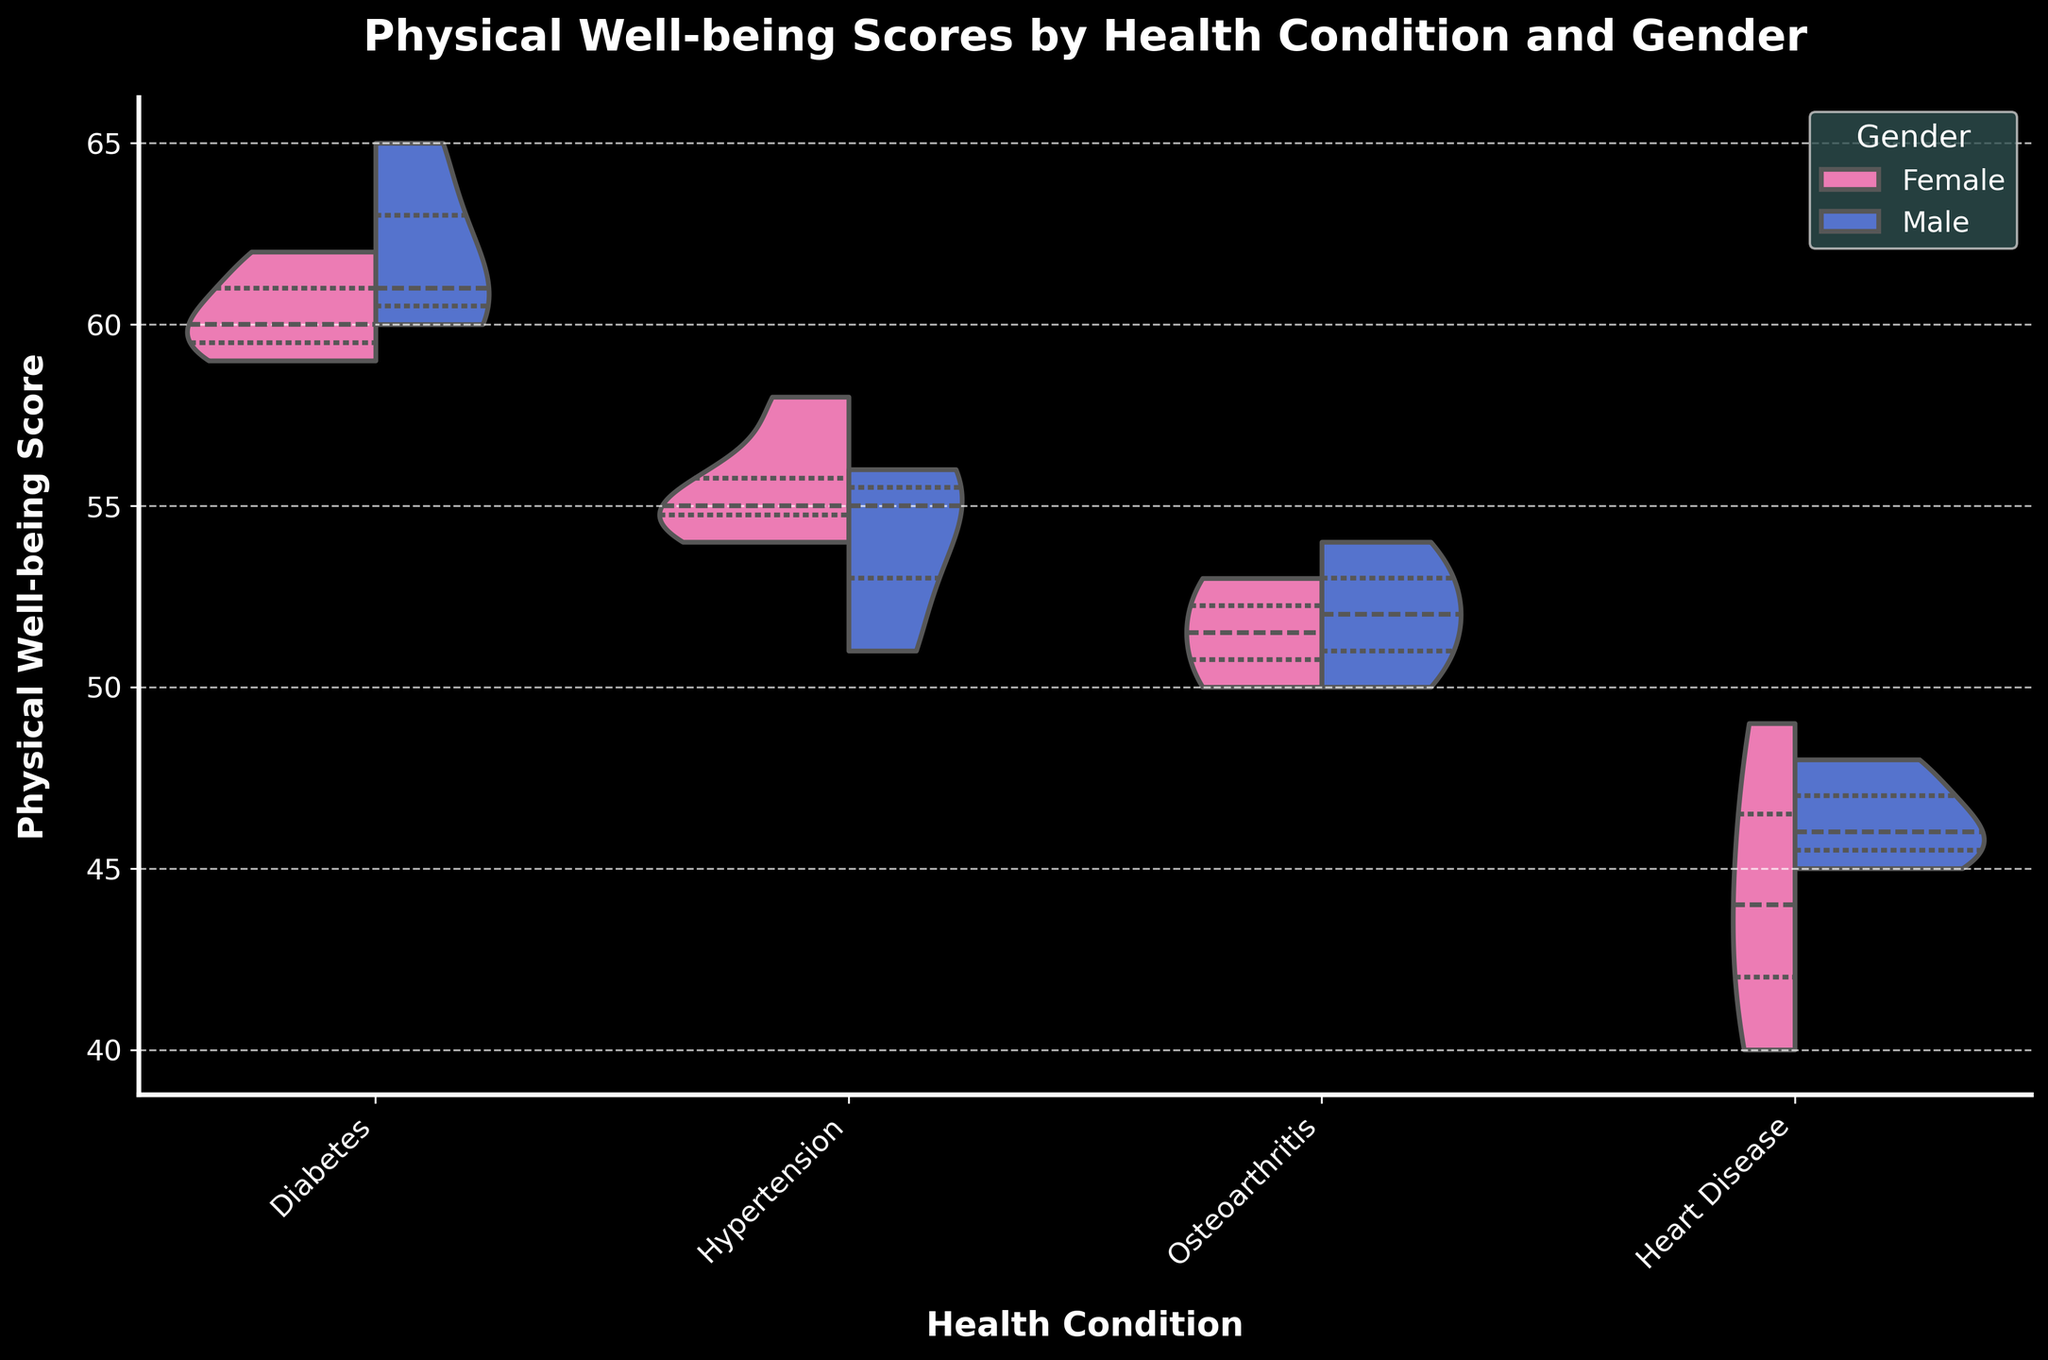What is the title of the chart? The title is displayed at the top center of the chart, indicating the overall context of the data represented.
Answer: Physical Well-being Scores by Health Condition and Gender What are the two gender categories shown in the violin plot? Observing the legend, we can see two different colors representing "Female" and "Male" categories.
Answer: Female and Male Which health condition shows the highest median Physical Well-being Score for females? By looking at the quartile lines within the violin plots for females, we identify the median for each condition and compare.
Answer: Diabetes How does the Physical Well-being Score distribution for males with Heart Disease compare to females with Heart Disease? By examining the male and female distributions within the Heart Disease category, we see the range and quartile distributions.
Answer: Males have a lower median score with a narrower distribution Which health condition has the widest range of Physical Well-being Scores for females? By comparing the spread of the violin plots for females across different health conditions, the condition with the largest spread is identified.
Answer: Hypertension What is the median Physical Well-being Score for males with Diabetes? The median score is represented by the thick middle line in the male section of the Diabetes violin plot.
Answer: 61 Which gender shows a greater variability in Physical Well-being Scores for Osteoarthritis? By observing the width and spread of the violin plots for both genders within the Osteoarthritis category, we can determine variability.
Answer: Male How does the median Physical Well-being Score for females with Diabetes compare to females with Hypertension? We compare the median quartile lines (thick lines) within the violin plots for females under Diabetes and Hypertension.
Answer: Higher in Diabetes Which health condition shows the closest median Physical Well-being Scores between males and females? By comparing median lines for each health condition category, observe which one has the least difference between genders.
Answer: Osteoarthritis What is the lowest Physical Well-being Score observed in the chart? Look at the minimum y-values for all categories in both the male and female sections of the violin plots.
Answer: 40 